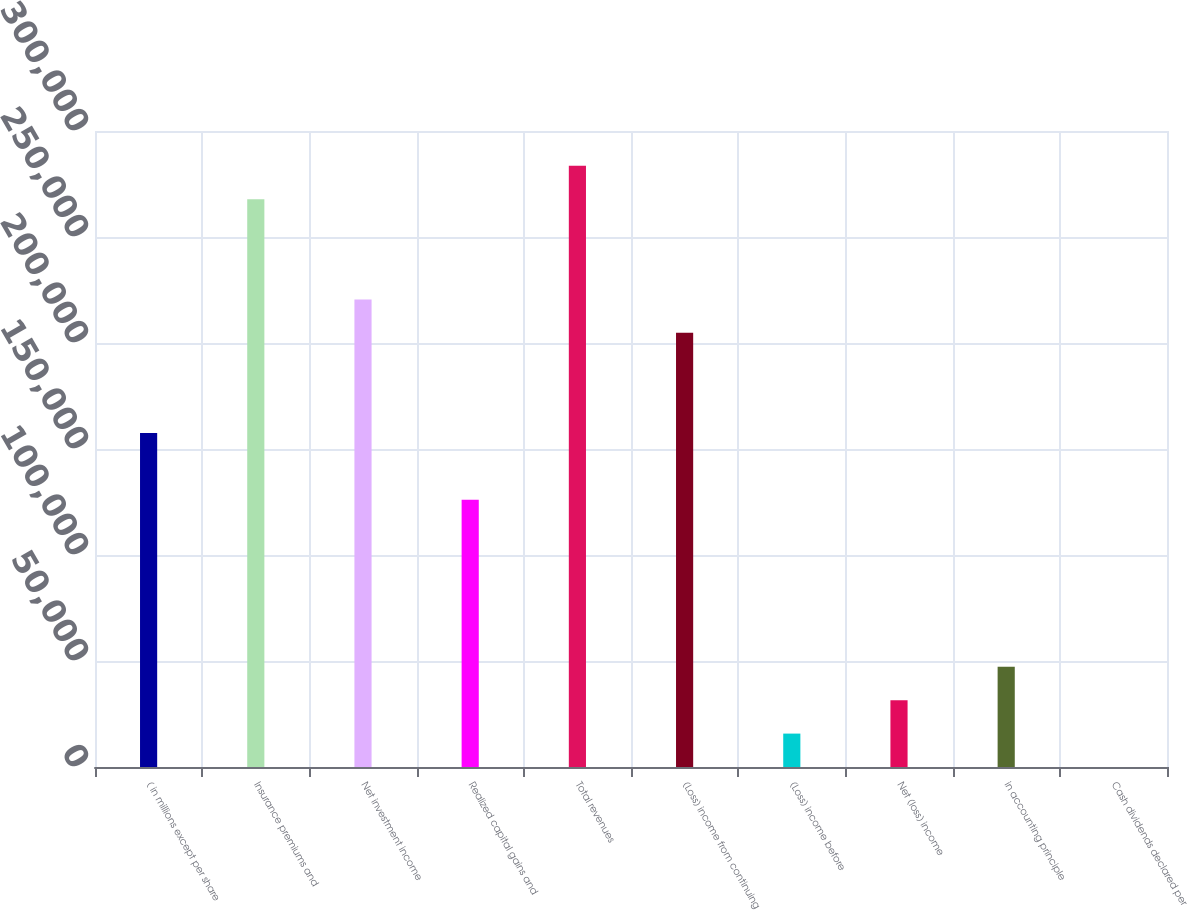Convert chart to OTSL. <chart><loc_0><loc_0><loc_500><loc_500><bar_chart><fcel>( in millions except per share<fcel>Insurance premiums and<fcel>Net investment income<fcel>Realized capital gains and<fcel>Total revenues<fcel>(Loss) income from continuing<fcel>(Loss) income before<fcel>Net (loss) income<fcel>in accounting principle<fcel>Cash dividends declared per<nl><fcel>157554<fcel>267841<fcel>220575<fcel>126043<fcel>283596<fcel>204820<fcel>15756.7<fcel>31511.9<fcel>47267.2<fcel>1.4<nl></chart> 